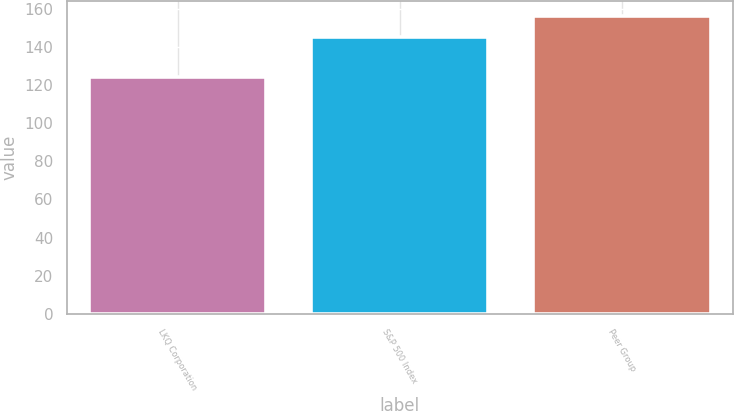Convert chart. <chart><loc_0><loc_0><loc_500><loc_500><bar_chart><fcel>LKQ Corporation<fcel>S&P 500 Index<fcel>Peer Group<nl><fcel>124<fcel>145<fcel>156<nl></chart> 